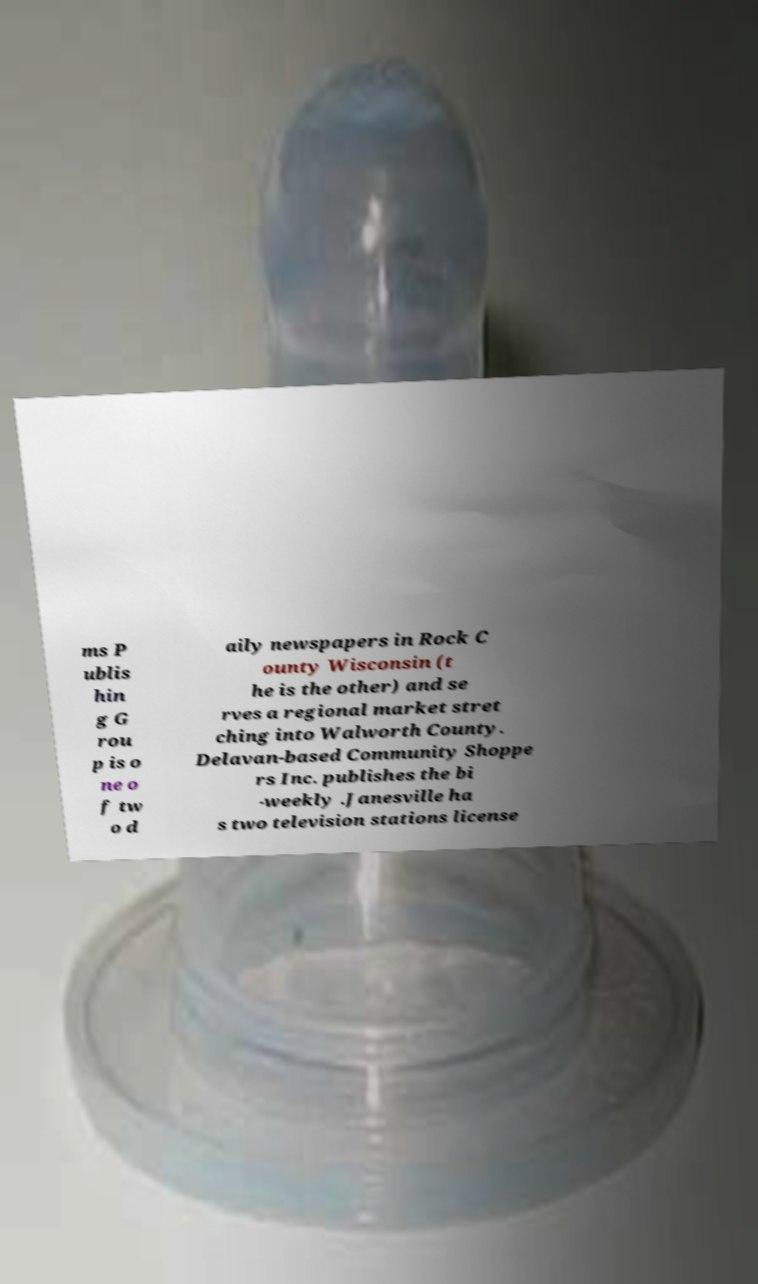Please identify and transcribe the text found in this image. ms P ublis hin g G rou p is o ne o f tw o d aily newspapers in Rock C ounty Wisconsin (t he is the other) and se rves a regional market stret ching into Walworth County. Delavan-based Community Shoppe rs Inc. publishes the bi -weekly .Janesville ha s two television stations license 